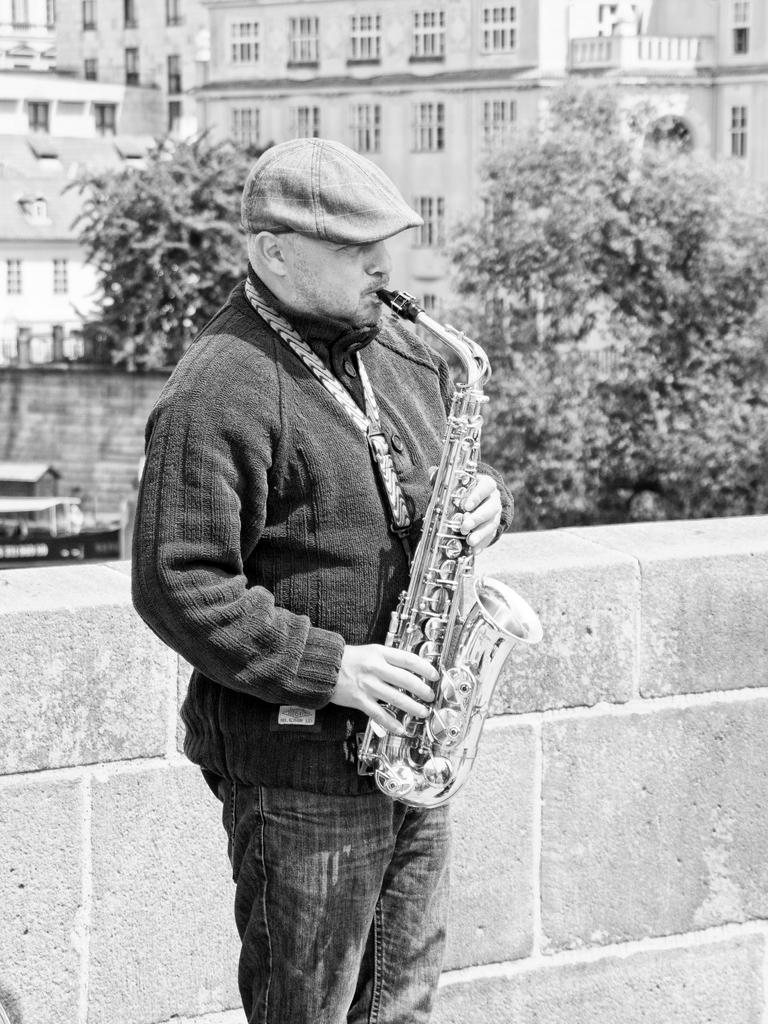What is the person in the image doing? The person is playing a saxophone. Can you describe the setting of the image? There is a window visible in the image, and there are buildings and trees in the background. What is the color scheme of the image? The image is in black and white mode. What type of power is being generated by the saxophone in the image? The saxophone is not generating any power in the image; it is a musical instrument being played by the person. Is there a recess happening in the image? There is no indication of a recess or break in the image; it simply shows a person playing a saxophone. 